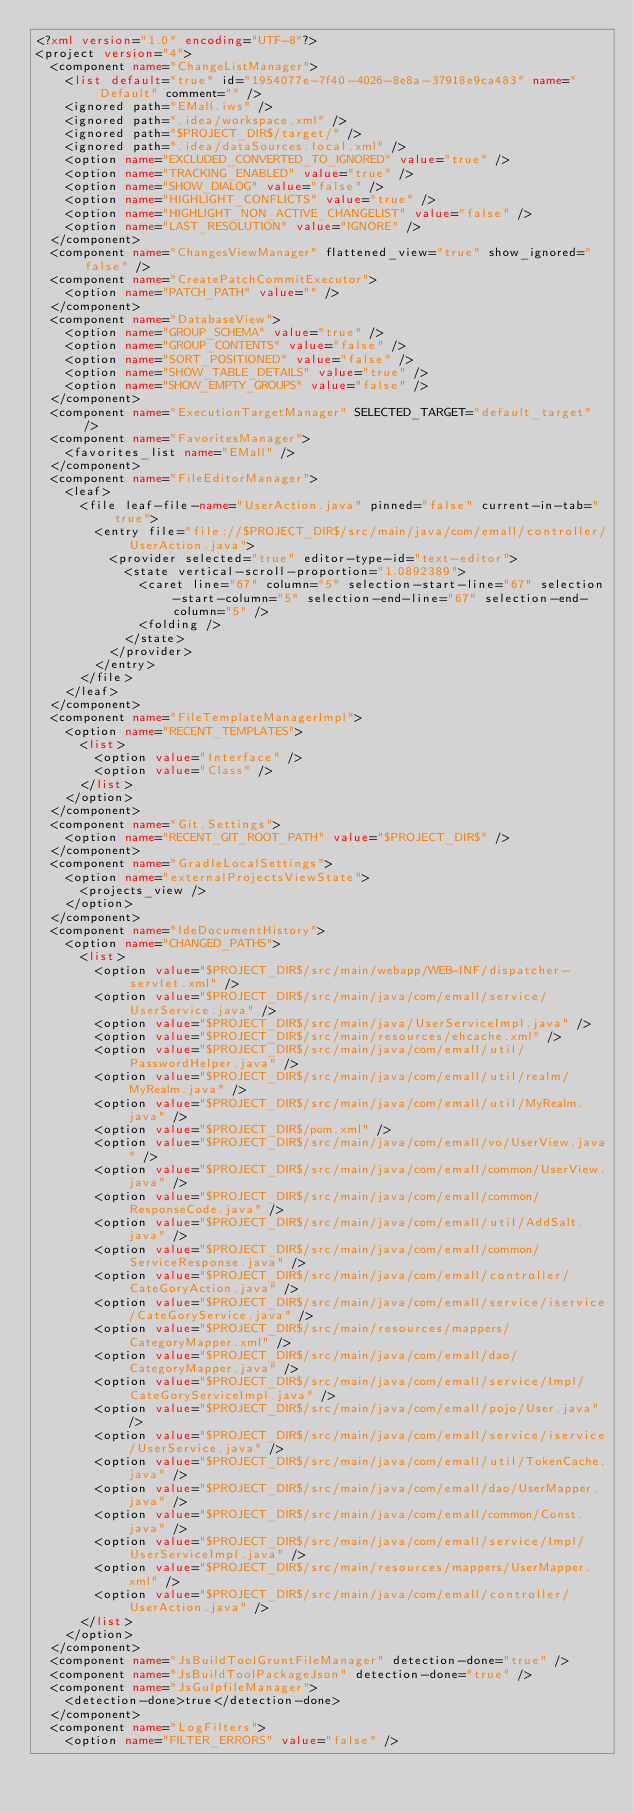Convert code to text. <code><loc_0><loc_0><loc_500><loc_500><_XML_><?xml version="1.0" encoding="UTF-8"?>
<project version="4">
  <component name="ChangeListManager">
    <list default="true" id="1954077e-7f40-4026-8e8a-37918e9ca483" name="Default" comment="" />
    <ignored path="EMall.iws" />
    <ignored path=".idea/workspace.xml" />
    <ignored path="$PROJECT_DIR$/target/" />
    <ignored path=".idea/dataSources.local.xml" />
    <option name="EXCLUDED_CONVERTED_TO_IGNORED" value="true" />
    <option name="TRACKING_ENABLED" value="true" />
    <option name="SHOW_DIALOG" value="false" />
    <option name="HIGHLIGHT_CONFLICTS" value="true" />
    <option name="HIGHLIGHT_NON_ACTIVE_CHANGELIST" value="false" />
    <option name="LAST_RESOLUTION" value="IGNORE" />
  </component>
  <component name="ChangesViewManager" flattened_view="true" show_ignored="false" />
  <component name="CreatePatchCommitExecutor">
    <option name="PATCH_PATH" value="" />
  </component>
  <component name="DatabaseView">
    <option name="GROUP_SCHEMA" value="true" />
    <option name="GROUP_CONTENTS" value="false" />
    <option name="SORT_POSITIONED" value="false" />
    <option name="SHOW_TABLE_DETAILS" value="true" />
    <option name="SHOW_EMPTY_GROUPS" value="false" />
  </component>
  <component name="ExecutionTargetManager" SELECTED_TARGET="default_target" />
  <component name="FavoritesManager">
    <favorites_list name="EMall" />
  </component>
  <component name="FileEditorManager">
    <leaf>
      <file leaf-file-name="UserAction.java" pinned="false" current-in-tab="true">
        <entry file="file://$PROJECT_DIR$/src/main/java/com/emall/controller/UserAction.java">
          <provider selected="true" editor-type-id="text-editor">
            <state vertical-scroll-proportion="1.0892389">
              <caret line="67" column="5" selection-start-line="67" selection-start-column="5" selection-end-line="67" selection-end-column="5" />
              <folding />
            </state>
          </provider>
        </entry>
      </file>
    </leaf>
  </component>
  <component name="FileTemplateManagerImpl">
    <option name="RECENT_TEMPLATES">
      <list>
        <option value="Interface" />
        <option value="Class" />
      </list>
    </option>
  </component>
  <component name="Git.Settings">
    <option name="RECENT_GIT_ROOT_PATH" value="$PROJECT_DIR$" />
  </component>
  <component name="GradleLocalSettings">
    <option name="externalProjectsViewState">
      <projects_view />
    </option>
  </component>
  <component name="IdeDocumentHistory">
    <option name="CHANGED_PATHS">
      <list>
        <option value="$PROJECT_DIR$/src/main/webapp/WEB-INF/dispatcher-servlet.xml" />
        <option value="$PROJECT_DIR$/src/main/java/com/emall/service/UserService.java" />
        <option value="$PROJECT_DIR$/src/main/java/UserServiceImpl.java" />
        <option value="$PROJECT_DIR$/src/main/resources/ehcache.xml" />
        <option value="$PROJECT_DIR$/src/main/java/com/emall/util/PasswordHelper.java" />
        <option value="$PROJECT_DIR$/src/main/java/com/emall/util/realm/MyRealm.java" />
        <option value="$PROJECT_DIR$/src/main/java/com/emall/util/MyRealm.java" />
        <option value="$PROJECT_DIR$/pom.xml" />
        <option value="$PROJECT_DIR$/src/main/java/com/emall/vo/UserView.java" />
        <option value="$PROJECT_DIR$/src/main/java/com/emall/common/UserView.java" />
        <option value="$PROJECT_DIR$/src/main/java/com/emall/common/ResponseCode.java" />
        <option value="$PROJECT_DIR$/src/main/java/com/emall/util/AddSalt.java" />
        <option value="$PROJECT_DIR$/src/main/java/com/emall/common/ServiceResponse.java" />
        <option value="$PROJECT_DIR$/src/main/java/com/emall/controller/CateGoryAction.java" />
        <option value="$PROJECT_DIR$/src/main/java/com/emall/service/iservice/CateGoryService.java" />
        <option value="$PROJECT_DIR$/src/main/resources/mappers/CategoryMapper.xml" />
        <option value="$PROJECT_DIR$/src/main/java/com/emall/dao/CategoryMapper.java" />
        <option value="$PROJECT_DIR$/src/main/java/com/emall/service/Impl/CateGoryServiceImpl.java" />
        <option value="$PROJECT_DIR$/src/main/java/com/emall/pojo/User.java" />
        <option value="$PROJECT_DIR$/src/main/java/com/emall/service/iservice/UserService.java" />
        <option value="$PROJECT_DIR$/src/main/java/com/emall/util/TokenCache.java" />
        <option value="$PROJECT_DIR$/src/main/java/com/emall/dao/UserMapper.java" />
        <option value="$PROJECT_DIR$/src/main/java/com/emall/common/Const.java" />
        <option value="$PROJECT_DIR$/src/main/java/com/emall/service/Impl/UserServiceImpl.java" />
        <option value="$PROJECT_DIR$/src/main/resources/mappers/UserMapper.xml" />
        <option value="$PROJECT_DIR$/src/main/java/com/emall/controller/UserAction.java" />
      </list>
    </option>
  </component>
  <component name="JsBuildToolGruntFileManager" detection-done="true" />
  <component name="JsBuildToolPackageJson" detection-done="true" />
  <component name="JsGulpfileManager">
    <detection-done>true</detection-done>
  </component>
  <component name="LogFilters">
    <option name="FILTER_ERRORS" value="false" /></code> 